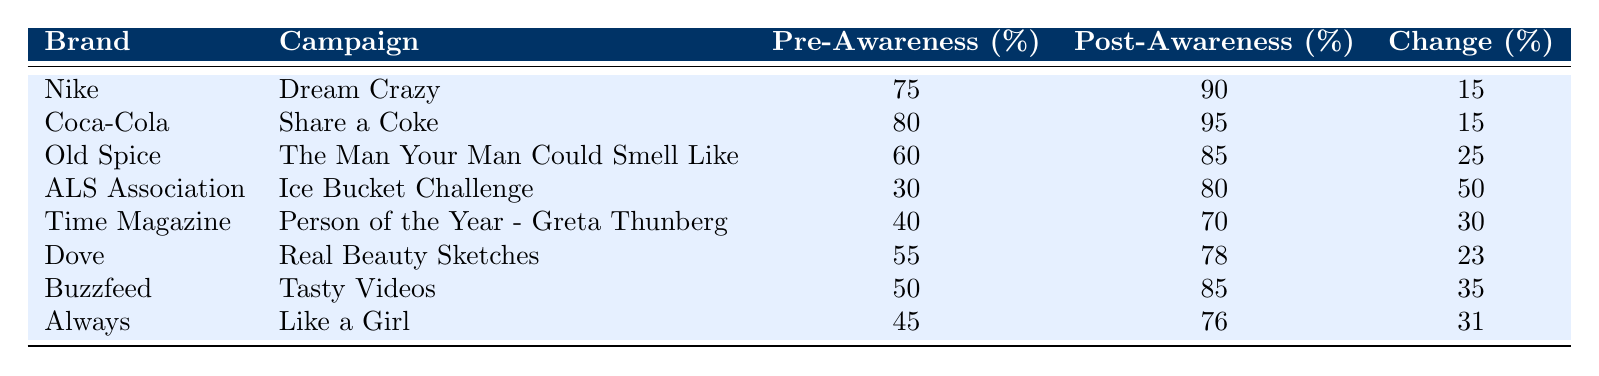What was the pre-campaign awareness for Nike? The table shows that the pre-campaign awareness for Nike was listed as 75%.
Answer: 75% What is the percentage increase in brand awareness for the ALS Association's campaign? The change in awareness for the ALS Association is listed as 50%, which indicates that their brand awareness increased by this percentage after the campaign.
Answer: 50% Did Old Spice's campaign achieve a higher change in awareness than Coca-Cola's campaign? Old Spice's change in awareness is 25%, while Coca-Cola's is 15%. Since 25% is greater than 15%, Old Spice did achieve a higher change in awareness.
Answer: Yes What was the average change in awareness across all campaigns? To find the average, sum the change in awareness values: 15 + 15 + 25 + 50 + 30 + 23 + 35 + 31 = 225. There are 8 campaigns, so 225 / 8 = 28.125.
Answer: 28.125 Is the post-campaign awareness for Always greater than the pre-campaign awareness for Dove? The post-campaign awareness for Always is 76%, and the pre-campaign awareness for Dove is 55%. Since 76% is greater than 55%, the statement is true.
Answer: Yes Which campaign had the highest post-campaign awareness? The campaign with the highest post-campaign awareness is for Coca-Cola, which is 95%.
Answer: 95% What is the difference in pre-campaign awareness between Buzzfeed and Time Magazine? Buzzfeed has a pre-campaign awareness of 50%, while Time Magazine has 40%. The difference is 50 - 40 = 10.
Answer: 10 Which brand experienced the least change in awareness after their campaign? By comparing the change in awareness values, Coca-Cola experienced the least change of 15%.
Answer: Coca-Cola What percentage of the brands had a post-campaign awareness of over 80%? The brands that had a post-campaign awareness of over 80% are Coca-Cola (95%), Old Spice (85%), ALS Association (80%), and Buzzfeed (85%). That’s 4 out of 8 brands, which is 50%.
Answer: 50% 